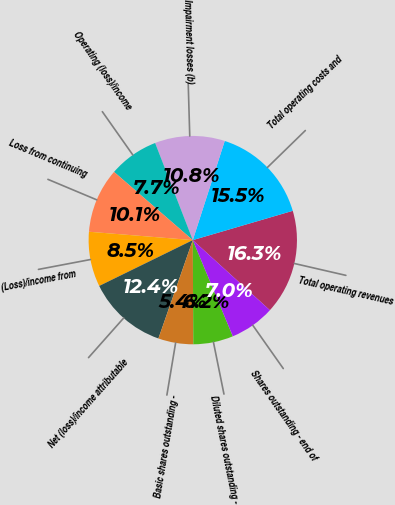<chart> <loc_0><loc_0><loc_500><loc_500><pie_chart><fcel>Total operating revenues<fcel>Total operating costs and<fcel>Impairment losses (b)<fcel>Operating (loss)/income<fcel>Loss from continuing<fcel>(Loss)/income from<fcel>Net (loss)/income attributable<fcel>Basic shares outstanding -<fcel>Diluted shares outstanding -<fcel>Shares outstanding - end of<nl><fcel>16.28%<fcel>15.5%<fcel>10.85%<fcel>7.75%<fcel>10.08%<fcel>8.53%<fcel>12.4%<fcel>5.43%<fcel>6.2%<fcel>6.98%<nl></chart> 